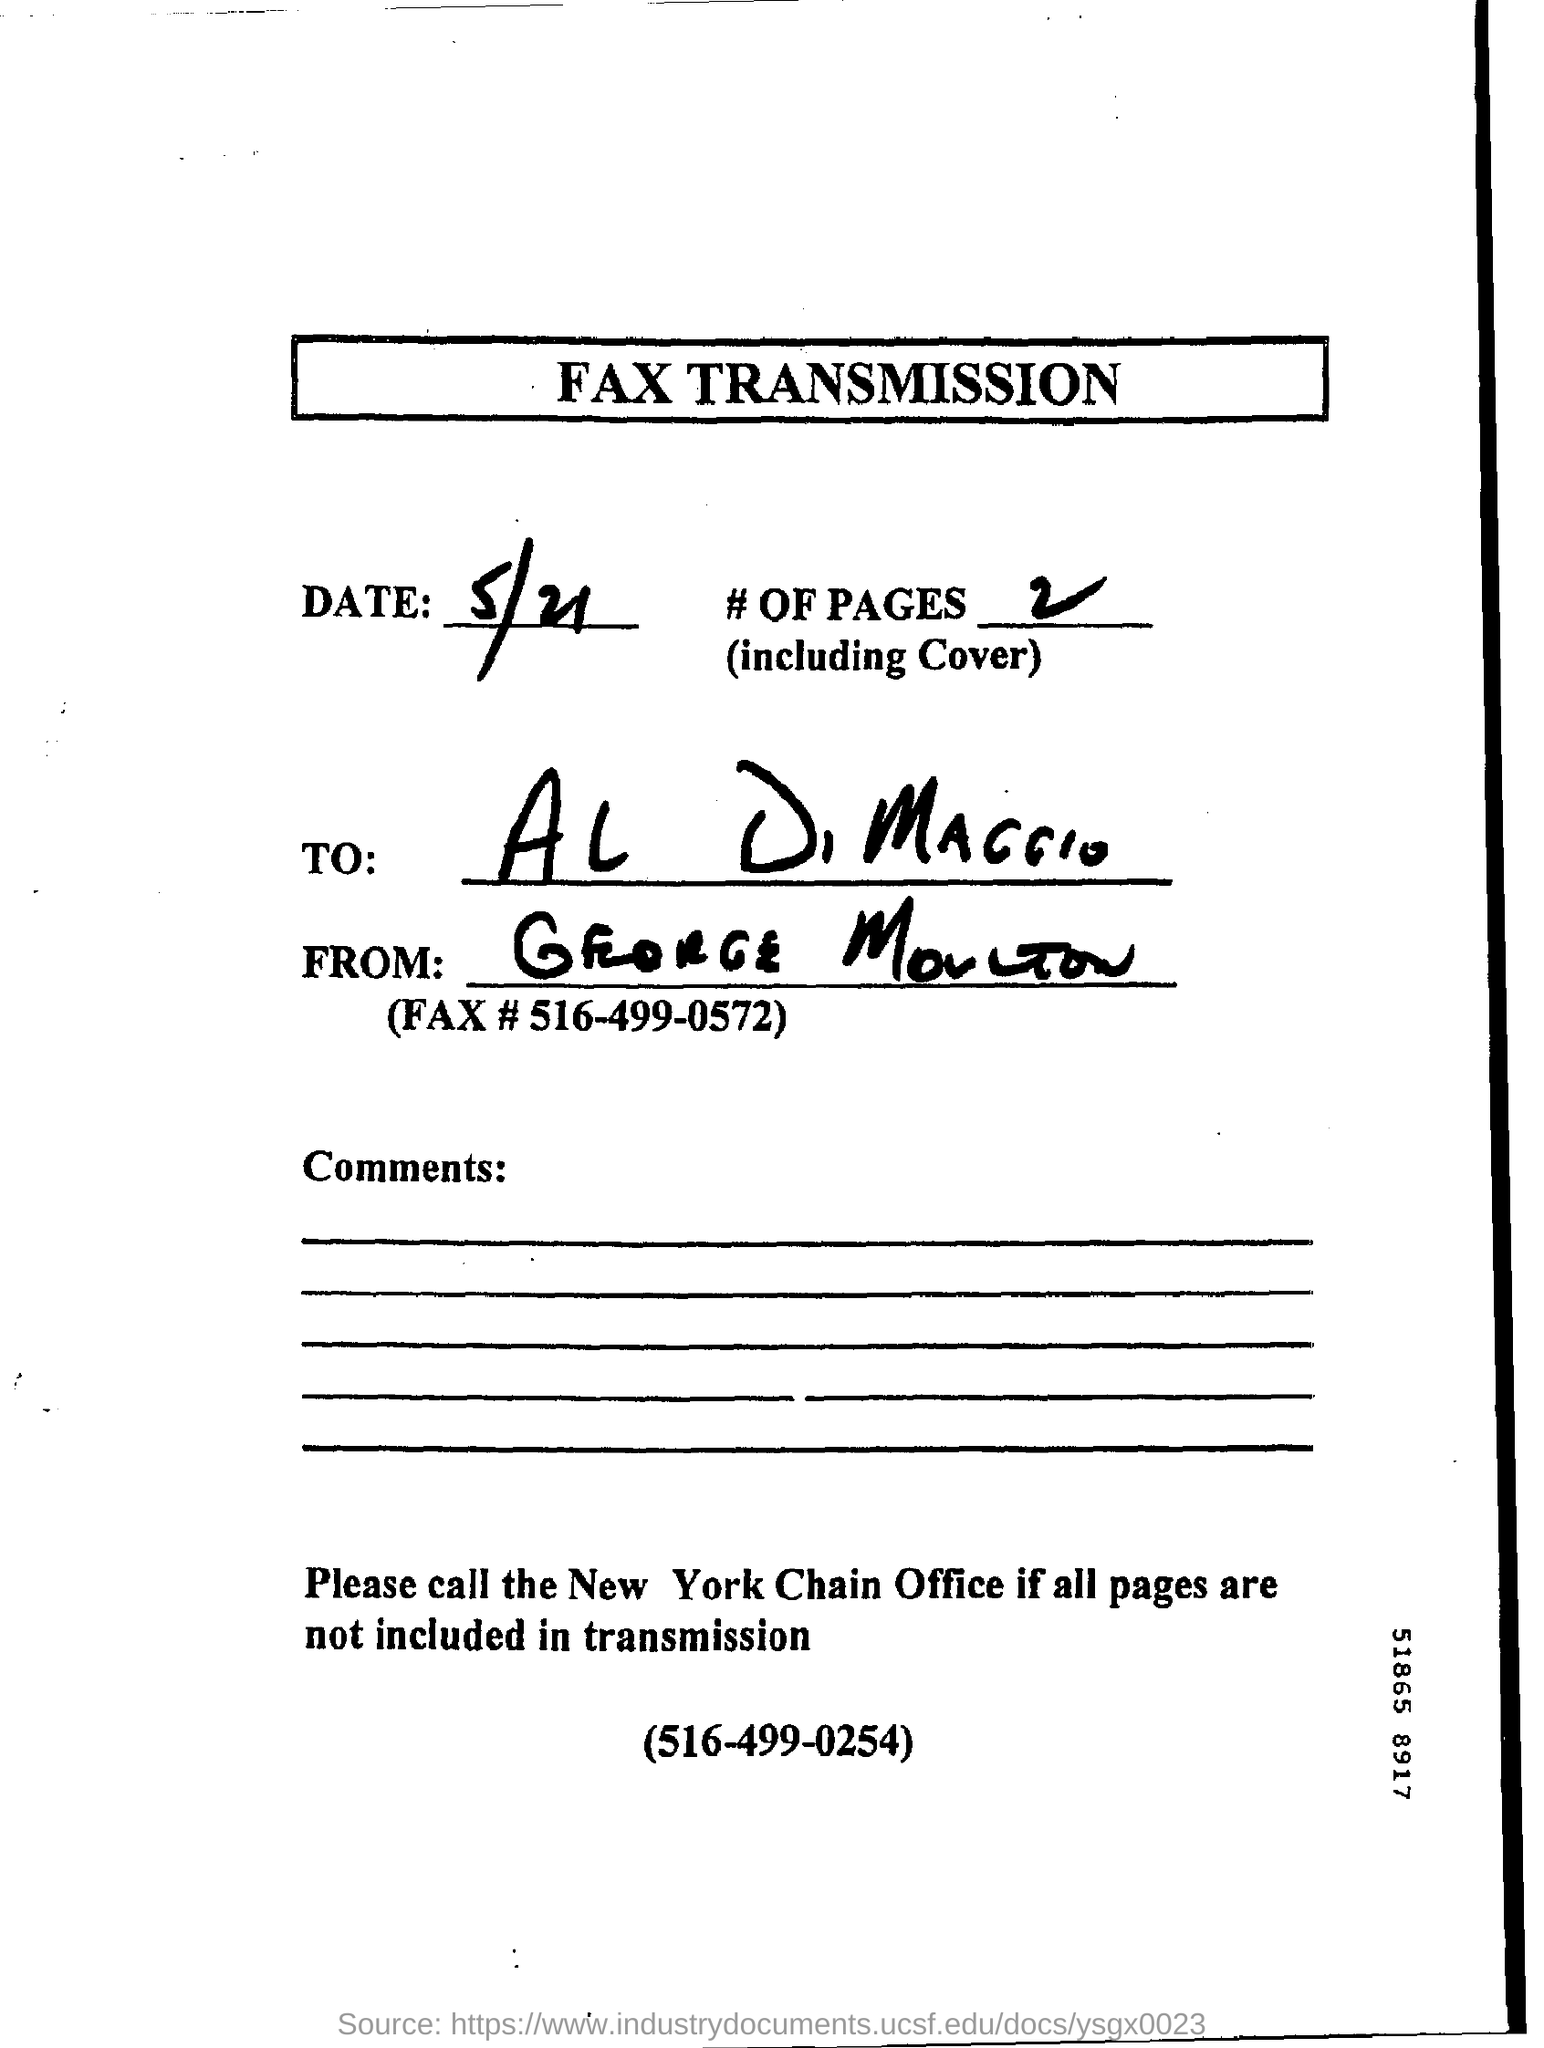Indicate a few pertinent items in this graphic. The title of the document is 'Fax Transmission.' The intended recipient of this message is Al DiMaggio. The number of pages is between 2 and... Please provide the fax number in the document, which is 516-499-0572. It is currently May 21st. 